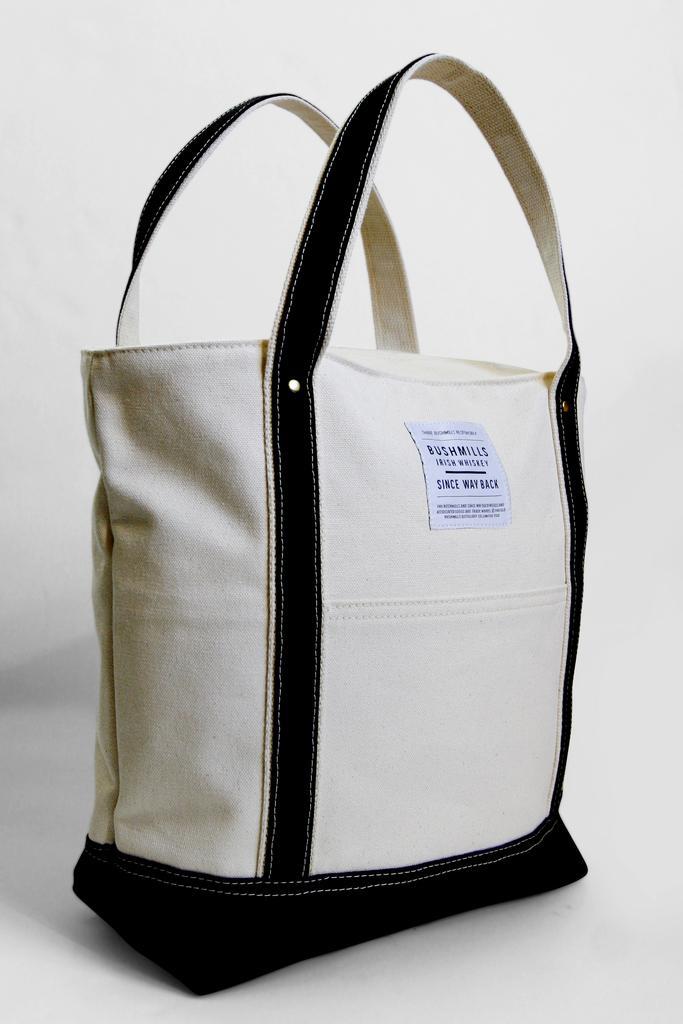How would you summarize this image in a sentence or two? This picture is mainly highlighted with a handbag. It is black and white in color. 